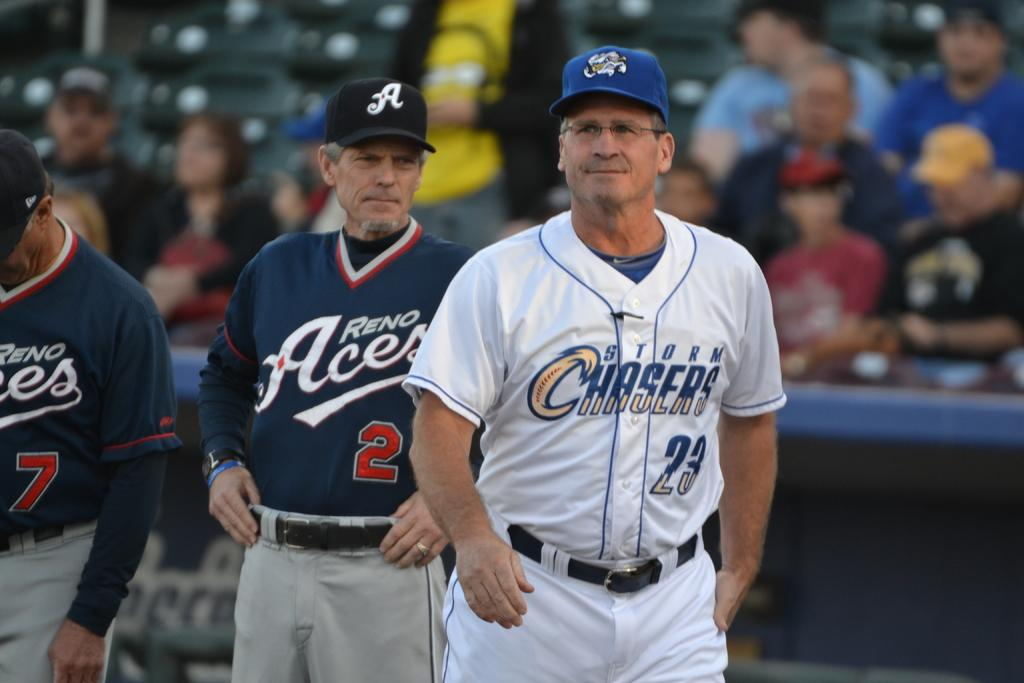<image>
Offer a succinct explanation of the picture presented. A baseball player in blue and white has the logo for the chasers on his shirt. 